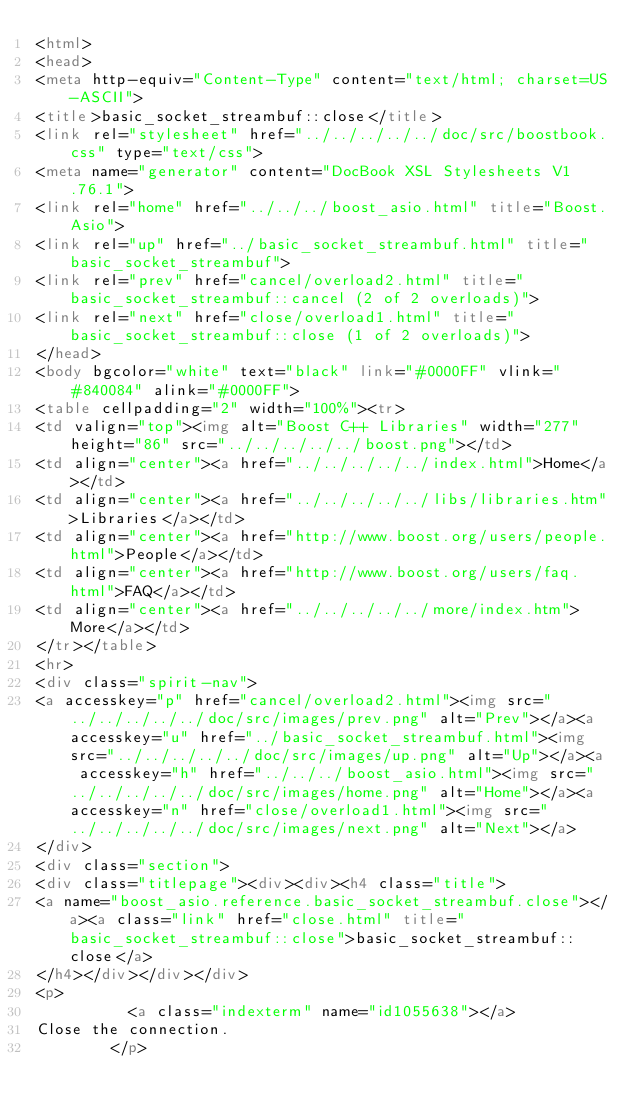<code> <loc_0><loc_0><loc_500><loc_500><_HTML_><html>
<head>
<meta http-equiv="Content-Type" content="text/html; charset=US-ASCII">
<title>basic_socket_streambuf::close</title>
<link rel="stylesheet" href="../../../../../doc/src/boostbook.css" type="text/css">
<meta name="generator" content="DocBook XSL Stylesheets V1.76.1">
<link rel="home" href="../../../boost_asio.html" title="Boost.Asio">
<link rel="up" href="../basic_socket_streambuf.html" title="basic_socket_streambuf">
<link rel="prev" href="cancel/overload2.html" title="basic_socket_streambuf::cancel (2 of 2 overloads)">
<link rel="next" href="close/overload1.html" title="basic_socket_streambuf::close (1 of 2 overloads)">
</head>
<body bgcolor="white" text="black" link="#0000FF" vlink="#840084" alink="#0000FF">
<table cellpadding="2" width="100%"><tr>
<td valign="top"><img alt="Boost C++ Libraries" width="277" height="86" src="../../../../../boost.png"></td>
<td align="center"><a href="../../../../../index.html">Home</a></td>
<td align="center"><a href="../../../../../libs/libraries.htm">Libraries</a></td>
<td align="center"><a href="http://www.boost.org/users/people.html">People</a></td>
<td align="center"><a href="http://www.boost.org/users/faq.html">FAQ</a></td>
<td align="center"><a href="../../../../../more/index.htm">More</a></td>
</tr></table>
<hr>
<div class="spirit-nav">
<a accesskey="p" href="cancel/overload2.html"><img src="../../../../../doc/src/images/prev.png" alt="Prev"></a><a accesskey="u" href="../basic_socket_streambuf.html"><img src="../../../../../doc/src/images/up.png" alt="Up"></a><a accesskey="h" href="../../../boost_asio.html"><img src="../../../../../doc/src/images/home.png" alt="Home"></a><a accesskey="n" href="close/overload1.html"><img src="../../../../../doc/src/images/next.png" alt="Next"></a>
</div>
<div class="section">
<div class="titlepage"><div><div><h4 class="title">
<a name="boost_asio.reference.basic_socket_streambuf.close"></a><a class="link" href="close.html" title="basic_socket_streambuf::close">basic_socket_streambuf::close</a>
</h4></div></div></div>
<p>
          <a class="indexterm" name="id1055638"></a> 
Close the connection.
        </p></code> 